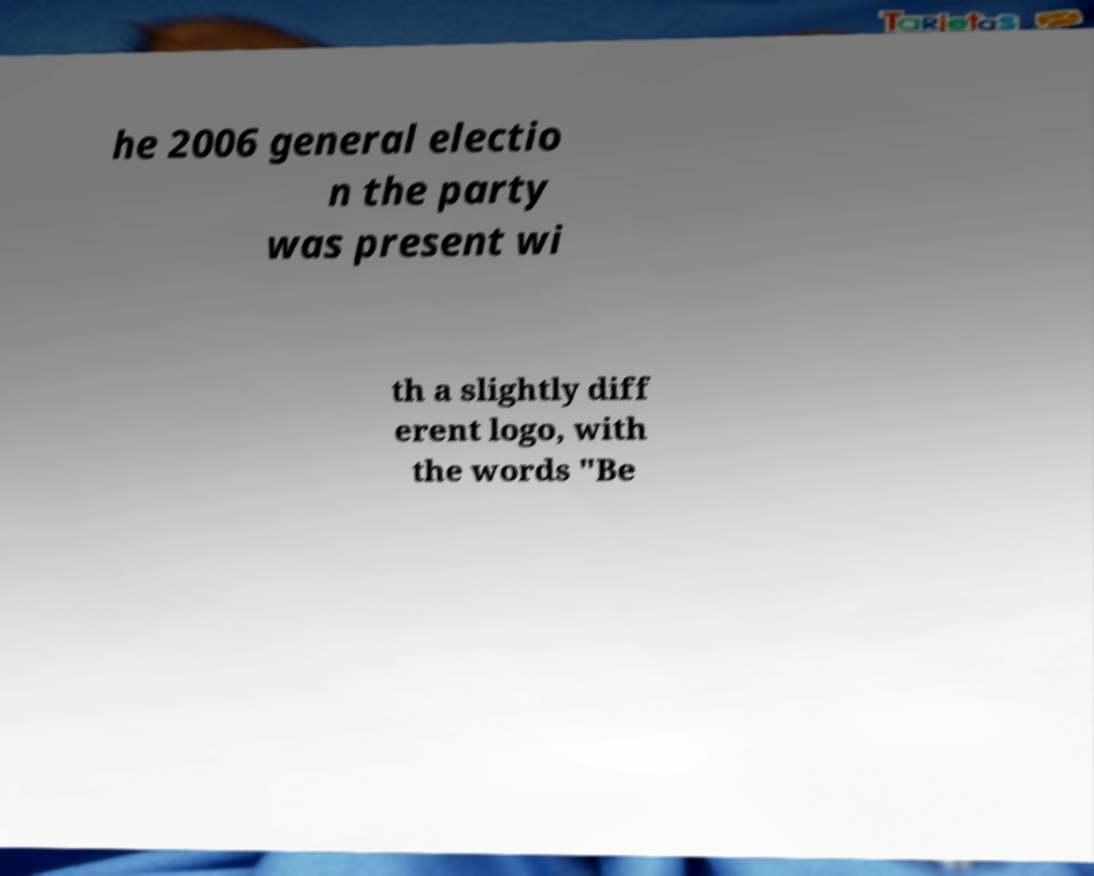Can you accurately transcribe the text from the provided image for me? he 2006 general electio n the party was present wi th a slightly diff erent logo, with the words "Be 